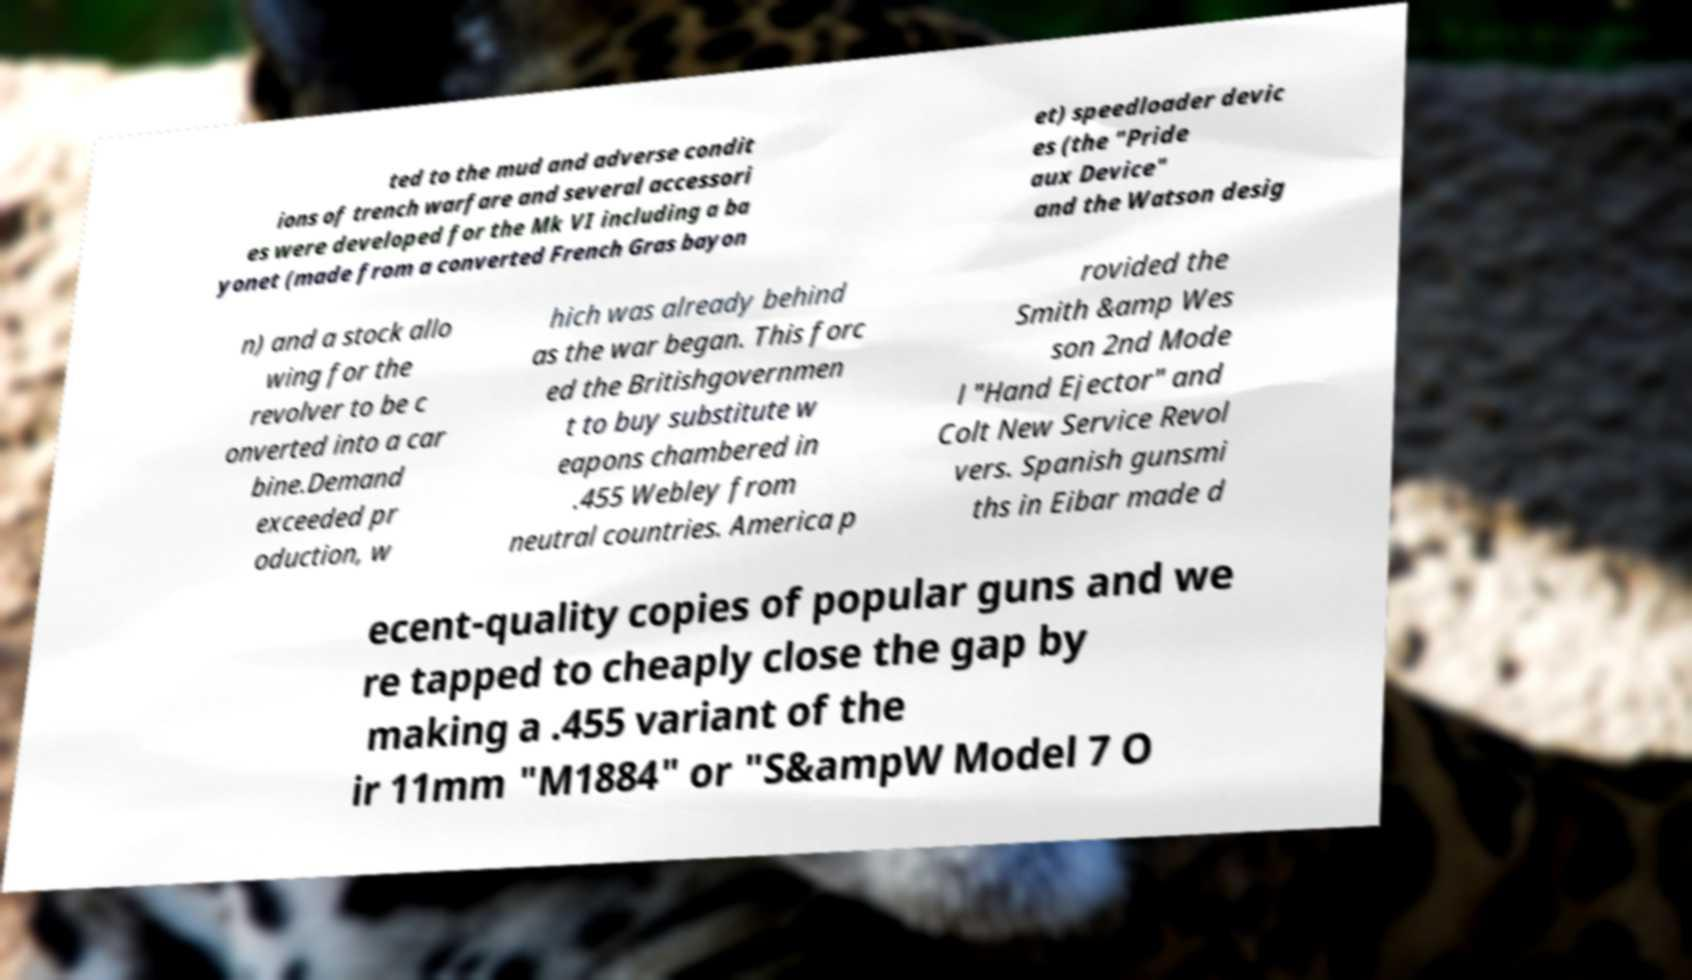Please read and relay the text visible in this image. What does it say? ted to the mud and adverse condit ions of trench warfare and several accessori es were developed for the Mk VI including a ba yonet (made from a converted French Gras bayon et) speedloader devic es (the "Pride aux Device" and the Watson desig n) and a stock allo wing for the revolver to be c onverted into a car bine.Demand exceeded pr oduction, w hich was already behind as the war began. This forc ed the Britishgovernmen t to buy substitute w eapons chambered in .455 Webley from neutral countries. America p rovided the Smith &amp Wes son 2nd Mode l "Hand Ejector" and Colt New Service Revol vers. Spanish gunsmi ths in Eibar made d ecent-quality copies of popular guns and we re tapped to cheaply close the gap by making a .455 variant of the ir 11mm "M1884" or "S&ampW Model 7 O 